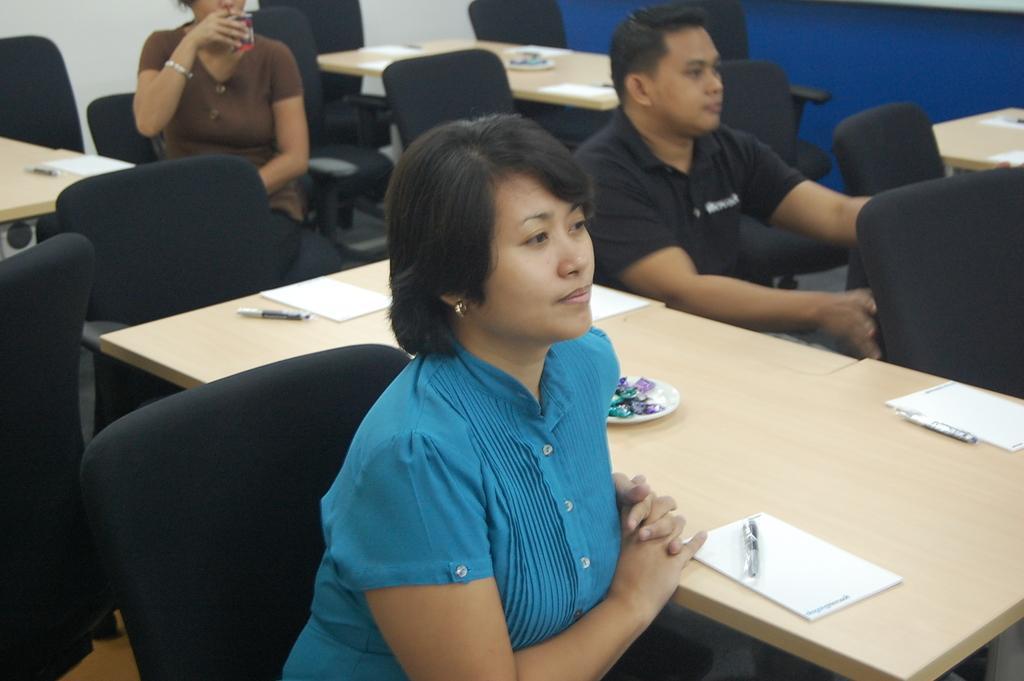Can you describe this image briefly? There are three people sitting in a black chair and there is a table beside them which has papers and some other objects on it. 